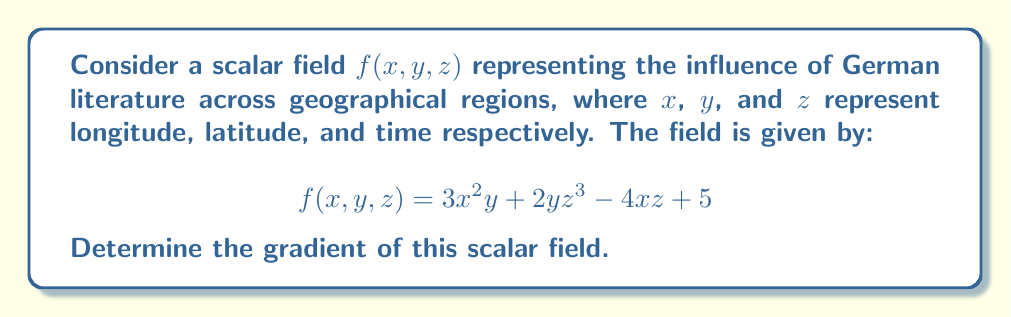What is the answer to this math problem? To find the gradient of the scalar field, we need to calculate the partial derivatives with respect to each variable:

1. Partial derivative with respect to $x$:
   $$\frac{\partial f}{\partial x} = 6xy - 4z$$

2. Partial derivative with respect to $y$:
   $$\frac{\partial f}{\partial y} = 3x^2 + 2z^3$$

3. Partial derivative with respect to $z$:
   $$\frac{\partial f}{\partial z} = 6yz^2 - 4x$$

The gradient is a vector field composed of these partial derivatives:

$$\nabla f = \left(\frac{\partial f}{\partial x}, \frac{\partial f}{\partial y}, \frac{\partial f}{\partial z}\right)$$

Substituting our calculated partial derivatives:

$$\nabla f = (6xy - 4z, 3x^2 + 2z^3, 6yz^2 - 4x)$$

This gradient represents the direction and magnitude of the greatest increase in literary influence across the geographical and temporal dimensions.
Answer: $\nabla f = (6xy - 4z, 3x^2 + 2z^3, 6yz^2 - 4x)$ 